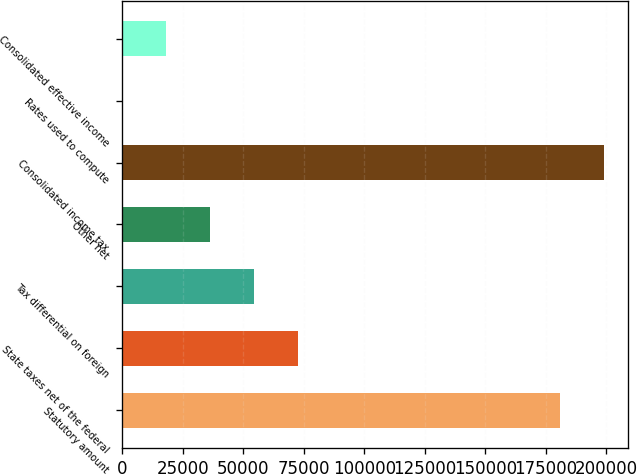<chart> <loc_0><loc_0><loc_500><loc_500><bar_chart><fcel>Statutory amount<fcel>State taxes net of the federal<fcel>Tax differential on foreign<fcel>Other net<fcel>Consolidated income tax<fcel>Rates used to compute<fcel>Consolidated effective income<nl><fcel>180831<fcel>72597<fcel>54456.5<fcel>36316<fcel>198972<fcel>35<fcel>18175.5<nl></chart> 